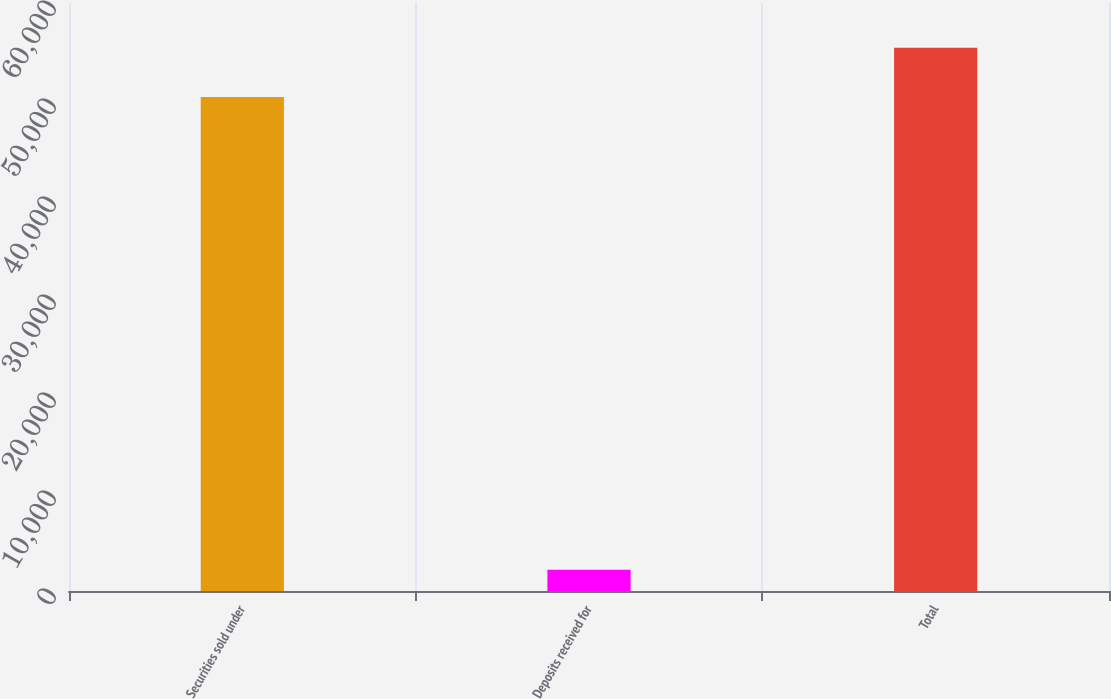Convert chart to OTSL. <chart><loc_0><loc_0><loc_500><loc_500><bar_chart><fcel>Securities sold under<fcel>Deposits received for<fcel>Total<nl><fcel>50399<fcel>2169<fcel>55438.9<nl></chart> 